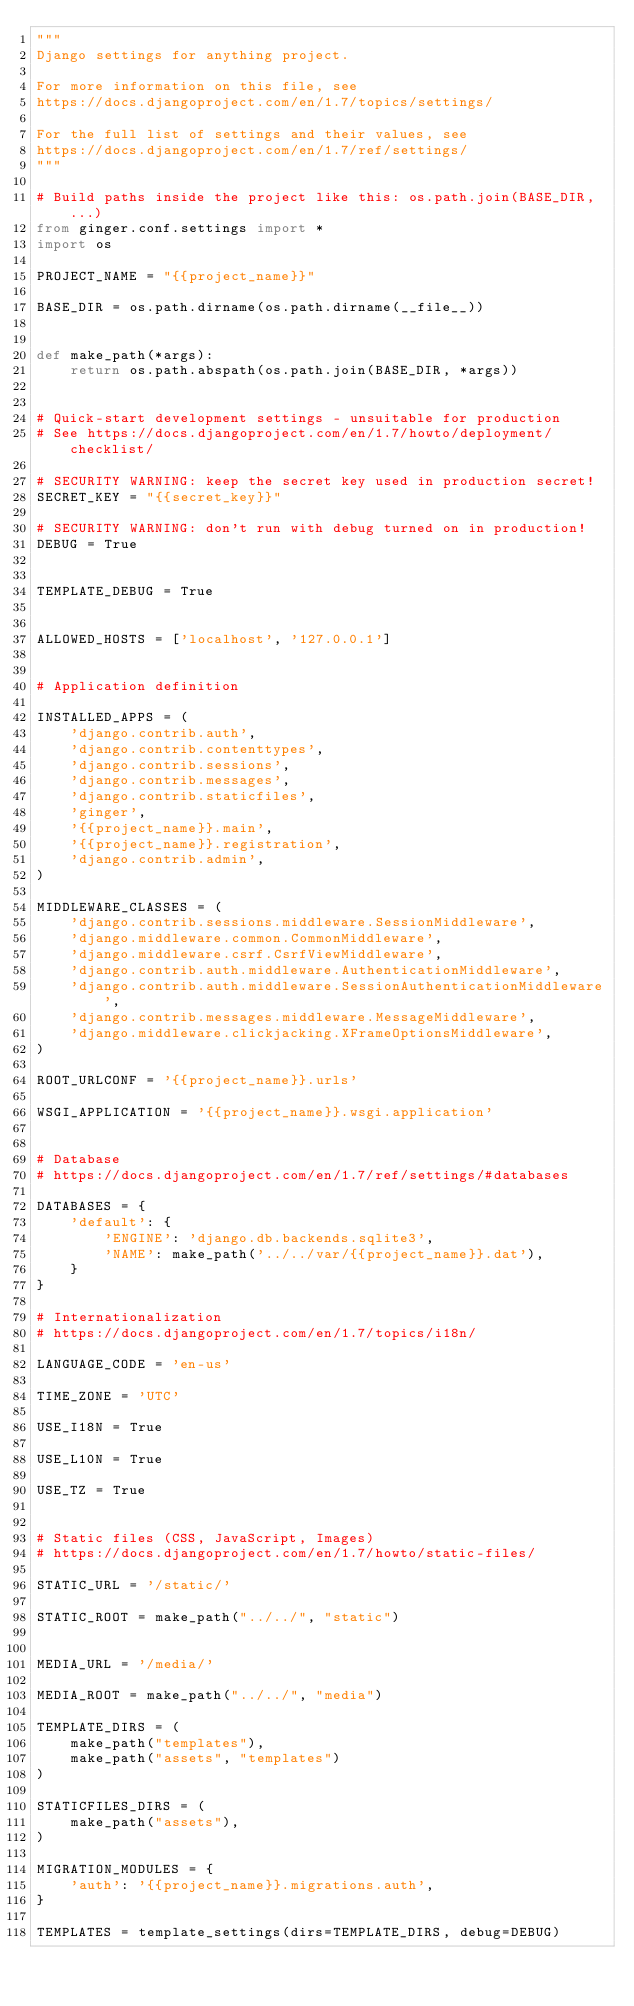Convert code to text. <code><loc_0><loc_0><loc_500><loc_500><_Python_>"""
Django settings for anything project.

For more information on this file, see
https://docs.djangoproject.com/en/1.7/topics/settings/

For the full list of settings and their values, see
https://docs.djangoproject.com/en/1.7/ref/settings/
"""

# Build paths inside the project like this: os.path.join(BASE_DIR, ...)
from ginger.conf.settings import *
import os

PROJECT_NAME = "{{project_name}}"

BASE_DIR = os.path.dirname(os.path.dirname(__file__))


def make_path(*args):
    return os.path.abspath(os.path.join(BASE_DIR, *args))


# Quick-start development settings - unsuitable for production
# See https://docs.djangoproject.com/en/1.7/howto/deployment/checklist/

# SECURITY WARNING: keep the secret key used in production secret!
SECRET_KEY = "{{secret_key}}"

# SECURITY WARNING: don't run with debug turned on in production!
DEBUG = True


TEMPLATE_DEBUG = True


ALLOWED_HOSTS = ['localhost', '127.0.0.1']


# Application definition

INSTALLED_APPS = (
    'django.contrib.auth',
    'django.contrib.contenttypes',
    'django.contrib.sessions',
    'django.contrib.messages',
    'django.contrib.staticfiles',
    'ginger',
    '{{project_name}}.main',
    '{{project_name}}.registration',
    'django.contrib.admin',
)

MIDDLEWARE_CLASSES = (
    'django.contrib.sessions.middleware.SessionMiddleware',
    'django.middleware.common.CommonMiddleware',
    'django.middleware.csrf.CsrfViewMiddleware',
    'django.contrib.auth.middleware.AuthenticationMiddleware',
    'django.contrib.auth.middleware.SessionAuthenticationMiddleware',
    'django.contrib.messages.middleware.MessageMiddleware',
    'django.middleware.clickjacking.XFrameOptionsMiddleware',
)

ROOT_URLCONF = '{{project_name}}.urls'

WSGI_APPLICATION = '{{project_name}}.wsgi.application'


# Database
# https://docs.djangoproject.com/en/1.7/ref/settings/#databases

DATABASES = {
    'default': {
        'ENGINE': 'django.db.backends.sqlite3',
        'NAME': make_path('../../var/{{project_name}}.dat'),
    }
}

# Internationalization
# https://docs.djangoproject.com/en/1.7/topics/i18n/

LANGUAGE_CODE = 'en-us'

TIME_ZONE = 'UTC'

USE_I18N = True

USE_L10N = True

USE_TZ = True


# Static files (CSS, JavaScript, Images)
# https://docs.djangoproject.com/en/1.7/howto/static-files/

STATIC_URL = '/static/'

STATIC_ROOT = make_path("../../", "static")


MEDIA_URL = '/media/'

MEDIA_ROOT = make_path("../../", "media")

TEMPLATE_DIRS = (
    make_path("templates"),
    make_path("assets", "templates")
)

STATICFILES_DIRS = (
    make_path("assets"),
)

MIGRATION_MODULES = {
    'auth': '{{project_name}}.migrations.auth',
}

TEMPLATES = template_settings(dirs=TEMPLATE_DIRS, debug=DEBUG)</code> 